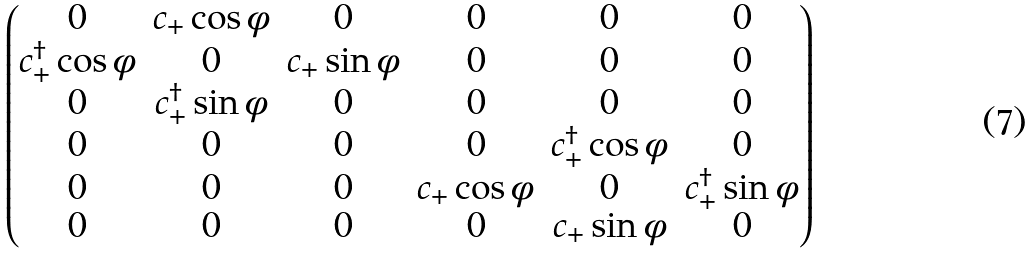<formula> <loc_0><loc_0><loc_500><loc_500>\begin{pmatrix} 0 & c _ { + } \cos \phi & 0 & 0 & 0 & 0 \\ c ^ { \dagger } _ { + } \cos \phi & 0 & c _ { + } \sin \phi & 0 & 0 & 0 \\ 0 & c ^ { \dagger } _ { + } \sin \phi & 0 & 0 & 0 & 0 \\ 0 & 0 & 0 & 0 & c ^ { \dagger } _ { + } \cos \phi & 0 \\ 0 & 0 & 0 & c _ { + } \cos \phi & 0 & c ^ { \dagger } _ { + } \sin \phi \\ 0 & 0 & 0 & 0 & c _ { + } \sin \phi & 0 \\ \end{pmatrix}</formula> 